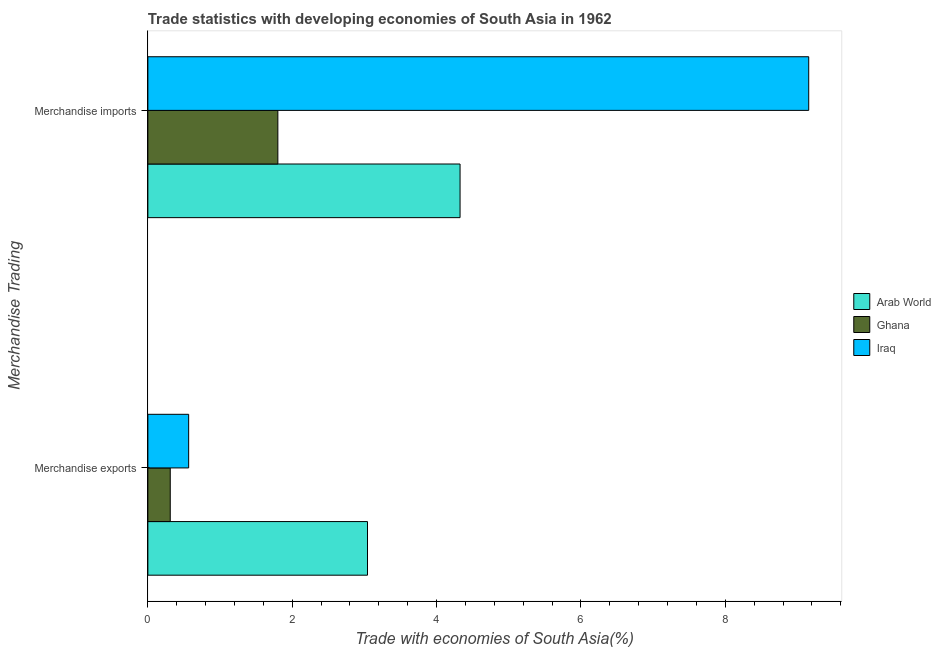Are the number of bars on each tick of the Y-axis equal?
Provide a succinct answer. Yes. How many bars are there on the 1st tick from the bottom?
Offer a terse response. 3. What is the label of the 1st group of bars from the top?
Keep it short and to the point. Merchandise imports. What is the merchandise imports in Arab World?
Your answer should be compact. 4.32. Across all countries, what is the maximum merchandise exports?
Provide a succinct answer. 3.04. Across all countries, what is the minimum merchandise exports?
Ensure brevity in your answer.  0.31. In which country was the merchandise exports maximum?
Offer a very short reply. Arab World. What is the total merchandise exports in the graph?
Your response must be concise. 3.92. What is the difference between the merchandise exports in Iraq and that in Arab World?
Your response must be concise. -2.48. What is the difference between the merchandise exports in Ghana and the merchandise imports in Iraq?
Offer a terse response. -8.84. What is the average merchandise imports per country?
Your answer should be very brief. 5.09. What is the difference between the merchandise exports and merchandise imports in Ghana?
Your response must be concise. -1.49. What is the ratio of the merchandise imports in Iraq to that in Ghana?
Your answer should be very brief. 5.08. Is the merchandise exports in Iraq less than that in Ghana?
Give a very brief answer. No. What does the 3rd bar from the top in Merchandise imports represents?
Offer a terse response. Arab World. What does the 1st bar from the bottom in Merchandise imports represents?
Give a very brief answer. Arab World. Are the values on the major ticks of X-axis written in scientific E-notation?
Your response must be concise. No. Does the graph contain any zero values?
Your response must be concise. No. Does the graph contain grids?
Your response must be concise. No. How many legend labels are there?
Ensure brevity in your answer.  3. What is the title of the graph?
Provide a short and direct response. Trade statistics with developing economies of South Asia in 1962. What is the label or title of the X-axis?
Your response must be concise. Trade with economies of South Asia(%). What is the label or title of the Y-axis?
Your response must be concise. Merchandise Trading. What is the Trade with economies of South Asia(%) in Arab World in Merchandise exports?
Offer a terse response. 3.04. What is the Trade with economies of South Asia(%) in Ghana in Merchandise exports?
Give a very brief answer. 0.31. What is the Trade with economies of South Asia(%) of Iraq in Merchandise exports?
Give a very brief answer. 0.57. What is the Trade with economies of South Asia(%) in Arab World in Merchandise imports?
Keep it short and to the point. 4.32. What is the Trade with economies of South Asia(%) in Ghana in Merchandise imports?
Give a very brief answer. 1.8. What is the Trade with economies of South Asia(%) in Iraq in Merchandise imports?
Make the answer very short. 9.15. Across all Merchandise Trading, what is the maximum Trade with economies of South Asia(%) of Arab World?
Provide a succinct answer. 4.32. Across all Merchandise Trading, what is the maximum Trade with economies of South Asia(%) in Ghana?
Offer a terse response. 1.8. Across all Merchandise Trading, what is the maximum Trade with economies of South Asia(%) in Iraq?
Your response must be concise. 9.15. Across all Merchandise Trading, what is the minimum Trade with economies of South Asia(%) of Arab World?
Provide a short and direct response. 3.04. Across all Merchandise Trading, what is the minimum Trade with economies of South Asia(%) of Ghana?
Make the answer very short. 0.31. Across all Merchandise Trading, what is the minimum Trade with economies of South Asia(%) of Iraq?
Provide a short and direct response. 0.57. What is the total Trade with economies of South Asia(%) of Arab World in the graph?
Give a very brief answer. 7.37. What is the total Trade with economies of South Asia(%) in Ghana in the graph?
Keep it short and to the point. 2.11. What is the total Trade with economies of South Asia(%) of Iraq in the graph?
Ensure brevity in your answer.  9.72. What is the difference between the Trade with economies of South Asia(%) of Arab World in Merchandise exports and that in Merchandise imports?
Offer a terse response. -1.28. What is the difference between the Trade with economies of South Asia(%) in Ghana in Merchandise exports and that in Merchandise imports?
Your answer should be very brief. -1.49. What is the difference between the Trade with economies of South Asia(%) of Iraq in Merchandise exports and that in Merchandise imports?
Give a very brief answer. -8.59. What is the difference between the Trade with economies of South Asia(%) of Arab World in Merchandise exports and the Trade with economies of South Asia(%) of Ghana in Merchandise imports?
Give a very brief answer. 1.24. What is the difference between the Trade with economies of South Asia(%) in Arab World in Merchandise exports and the Trade with economies of South Asia(%) in Iraq in Merchandise imports?
Make the answer very short. -6.11. What is the difference between the Trade with economies of South Asia(%) in Ghana in Merchandise exports and the Trade with economies of South Asia(%) in Iraq in Merchandise imports?
Make the answer very short. -8.84. What is the average Trade with economies of South Asia(%) of Arab World per Merchandise Trading?
Provide a short and direct response. 3.68. What is the average Trade with economies of South Asia(%) in Ghana per Merchandise Trading?
Provide a succinct answer. 1.06. What is the average Trade with economies of South Asia(%) of Iraq per Merchandise Trading?
Provide a succinct answer. 4.86. What is the difference between the Trade with economies of South Asia(%) in Arab World and Trade with economies of South Asia(%) in Ghana in Merchandise exports?
Give a very brief answer. 2.73. What is the difference between the Trade with economies of South Asia(%) in Arab World and Trade with economies of South Asia(%) in Iraq in Merchandise exports?
Offer a very short reply. 2.48. What is the difference between the Trade with economies of South Asia(%) of Ghana and Trade with economies of South Asia(%) of Iraq in Merchandise exports?
Provide a short and direct response. -0.26. What is the difference between the Trade with economies of South Asia(%) in Arab World and Trade with economies of South Asia(%) in Ghana in Merchandise imports?
Your answer should be compact. 2.52. What is the difference between the Trade with economies of South Asia(%) of Arab World and Trade with economies of South Asia(%) of Iraq in Merchandise imports?
Your response must be concise. -4.83. What is the difference between the Trade with economies of South Asia(%) of Ghana and Trade with economies of South Asia(%) of Iraq in Merchandise imports?
Provide a succinct answer. -7.35. What is the ratio of the Trade with economies of South Asia(%) of Arab World in Merchandise exports to that in Merchandise imports?
Give a very brief answer. 0.7. What is the ratio of the Trade with economies of South Asia(%) in Ghana in Merchandise exports to that in Merchandise imports?
Provide a succinct answer. 0.17. What is the ratio of the Trade with economies of South Asia(%) of Iraq in Merchandise exports to that in Merchandise imports?
Keep it short and to the point. 0.06. What is the difference between the highest and the second highest Trade with economies of South Asia(%) in Arab World?
Your answer should be very brief. 1.28. What is the difference between the highest and the second highest Trade with economies of South Asia(%) of Ghana?
Provide a short and direct response. 1.49. What is the difference between the highest and the second highest Trade with economies of South Asia(%) in Iraq?
Your response must be concise. 8.59. What is the difference between the highest and the lowest Trade with economies of South Asia(%) of Arab World?
Give a very brief answer. 1.28. What is the difference between the highest and the lowest Trade with economies of South Asia(%) in Ghana?
Provide a succinct answer. 1.49. What is the difference between the highest and the lowest Trade with economies of South Asia(%) of Iraq?
Your response must be concise. 8.59. 